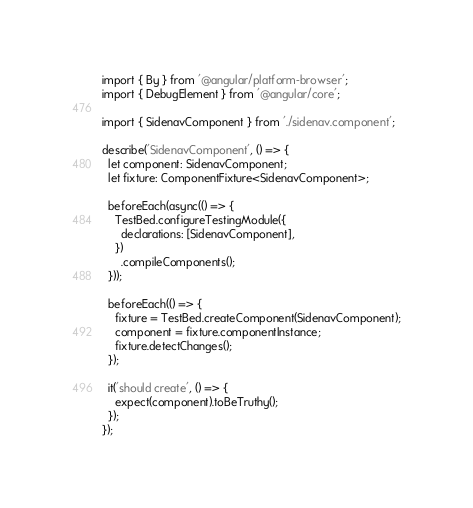<code> <loc_0><loc_0><loc_500><loc_500><_TypeScript_>import { By } from '@angular/platform-browser';
import { DebugElement } from '@angular/core';

import { SidenavComponent } from './sidenav.component';

describe('SidenavComponent', () => {
  let component: SidenavComponent;
  let fixture: ComponentFixture<SidenavComponent>;

  beforeEach(async(() => {
    TestBed.configureTestingModule({
      declarations: [SidenavComponent],
    })
      .compileComponents();
  }));

  beforeEach(() => {
    fixture = TestBed.createComponent(SidenavComponent);
    component = fixture.componentInstance;
    fixture.detectChanges();
  });

  it('should create', () => {
    expect(component).toBeTruthy();
  });
});
</code> 